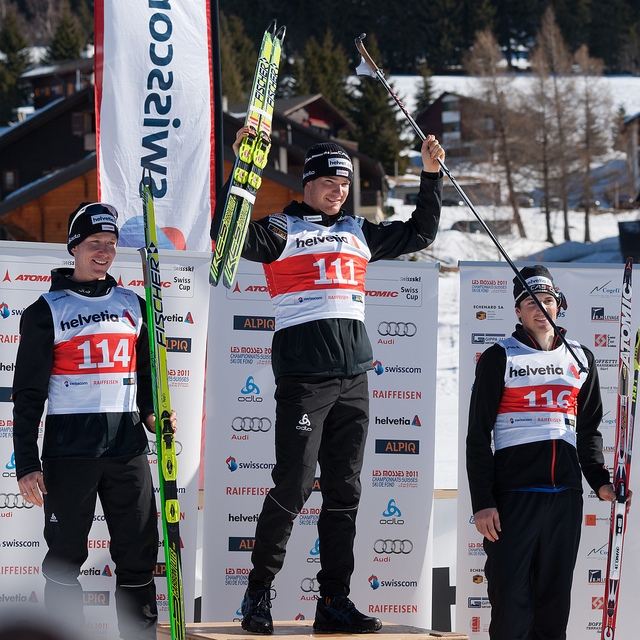How many zebras are there? 0 